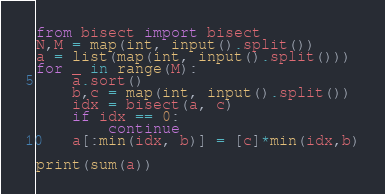Convert code to text. <code><loc_0><loc_0><loc_500><loc_500><_Python_>from bisect import bisect
N,M = map(int, input().split())
a = list(map(int, input().split()))
for _ in range(M):
    a.sort()
    b,c = map(int, input().split())
    idx = bisect(a, c)
    if idx == 0:
        continue
    a[:min(idx, b)] = [c]*min(idx,b)

print(sum(a))
</code> 